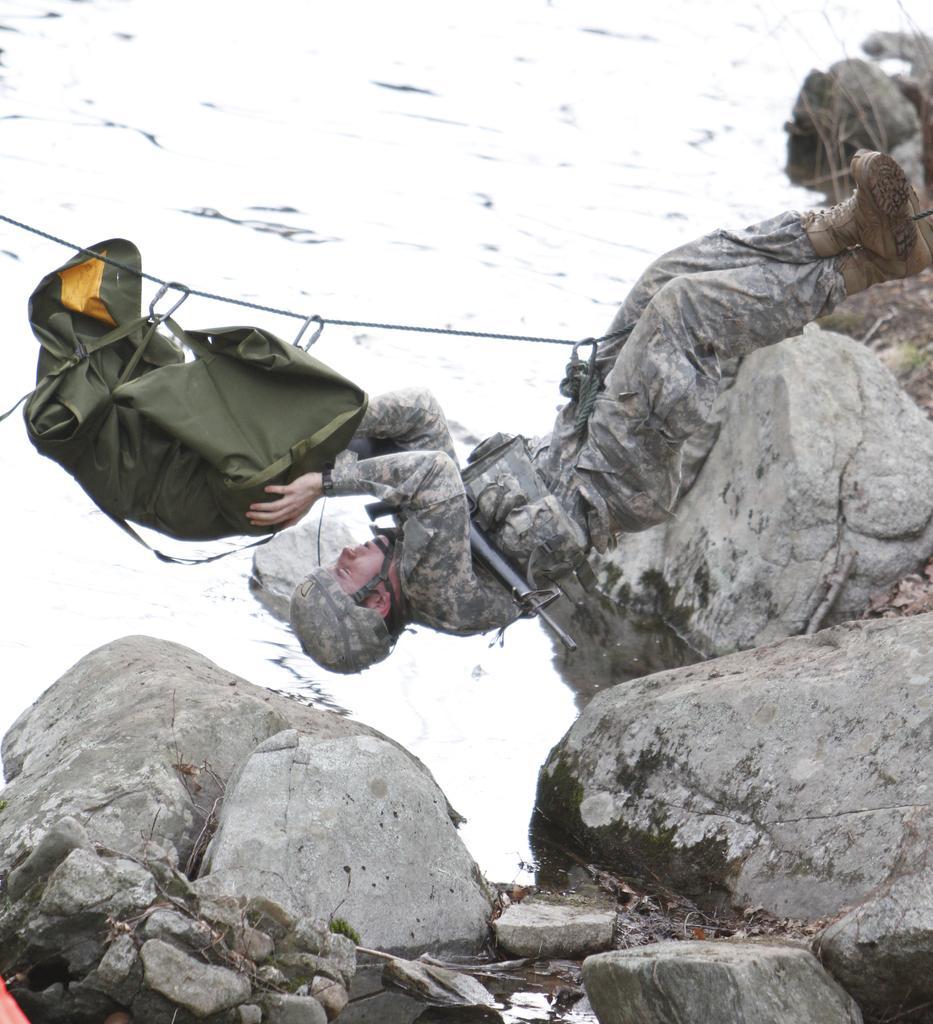Describe this image in one or two sentences. In the foreground of this image, at the bottom, there are rocks and in the middle, there is a man hanging to a rope and touching a bag which is hanging to a rope. in the background, there is water. 